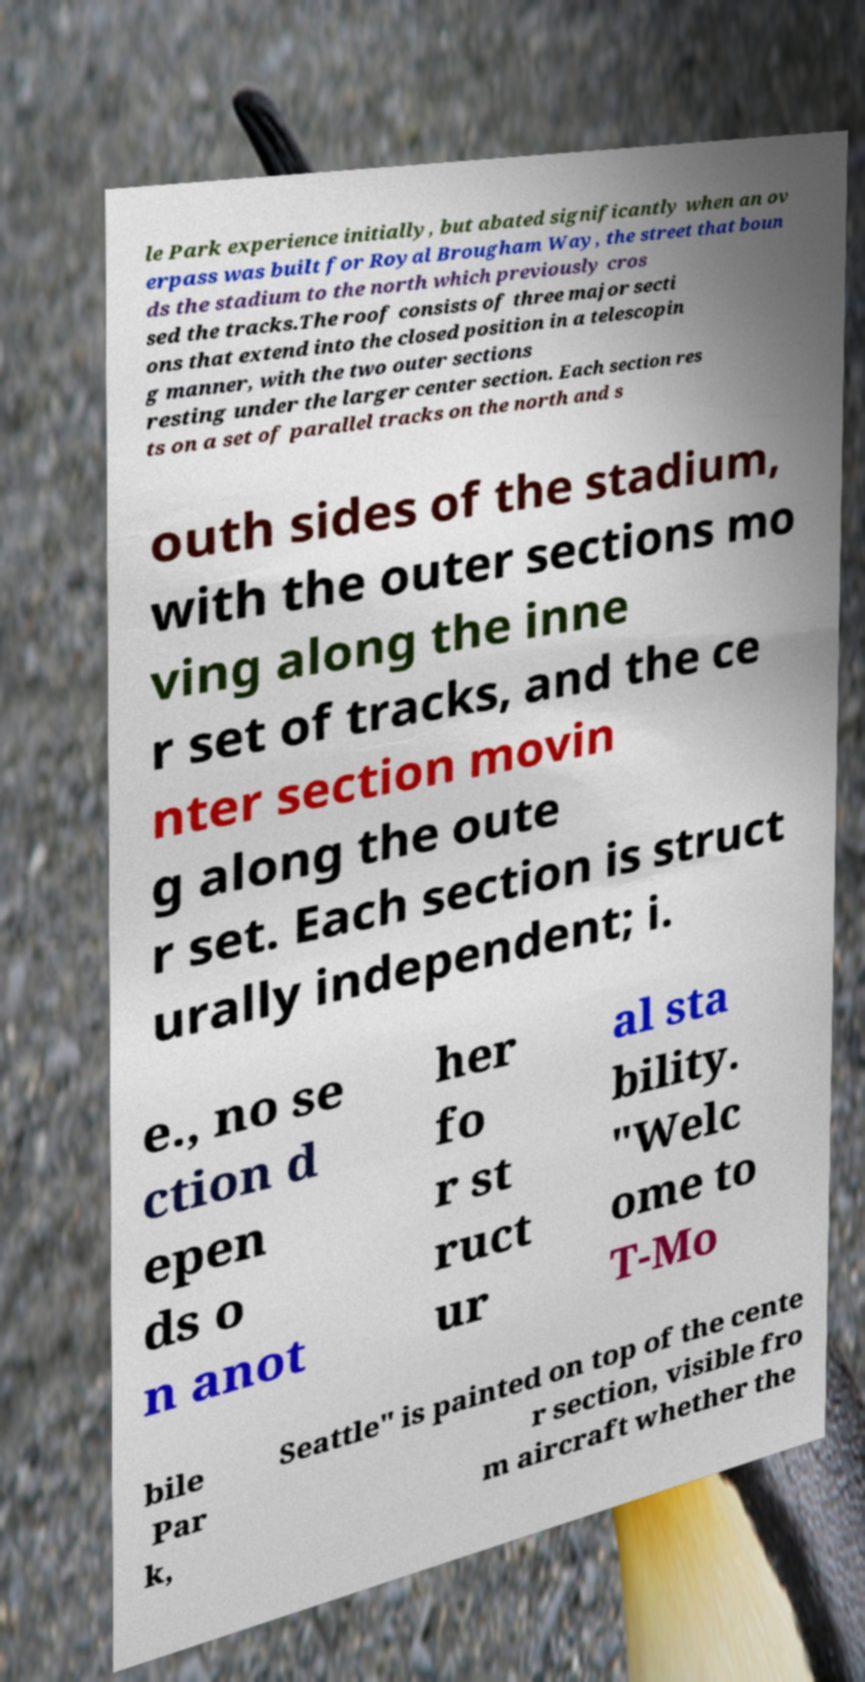Could you extract and type out the text from this image? le Park experience initially, but abated significantly when an ov erpass was built for Royal Brougham Way, the street that boun ds the stadium to the north which previously cros sed the tracks.The roof consists of three major secti ons that extend into the closed position in a telescopin g manner, with the two outer sections resting under the larger center section. Each section res ts on a set of parallel tracks on the north and s outh sides of the stadium, with the outer sections mo ving along the inne r set of tracks, and the ce nter section movin g along the oute r set. Each section is struct urally independent; i. e., no se ction d epen ds o n anot her fo r st ruct ur al sta bility. "Welc ome to T-Mo bile Par k, Seattle" is painted on top of the cente r section, visible fro m aircraft whether the 